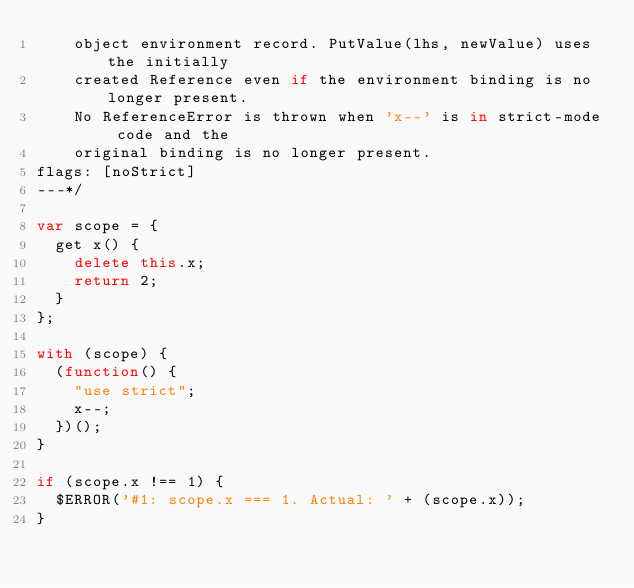<code> <loc_0><loc_0><loc_500><loc_500><_JavaScript_>    object environment record. PutValue(lhs, newValue) uses the initially
    created Reference even if the environment binding is no longer present.
    No ReferenceError is thrown when 'x--' is in strict-mode code and the
    original binding is no longer present.
flags: [noStrict]
---*/

var scope = {
  get x() {
    delete this.x;
    return 2;
  }
};

with (scope) {
  (function() {
    "use strict";
    x--;
  })();
}

if (scope.x !== 1) {
  $ERROR('#1: scope.x === 1. Actual: ' + (scope.x));
}
</code> 